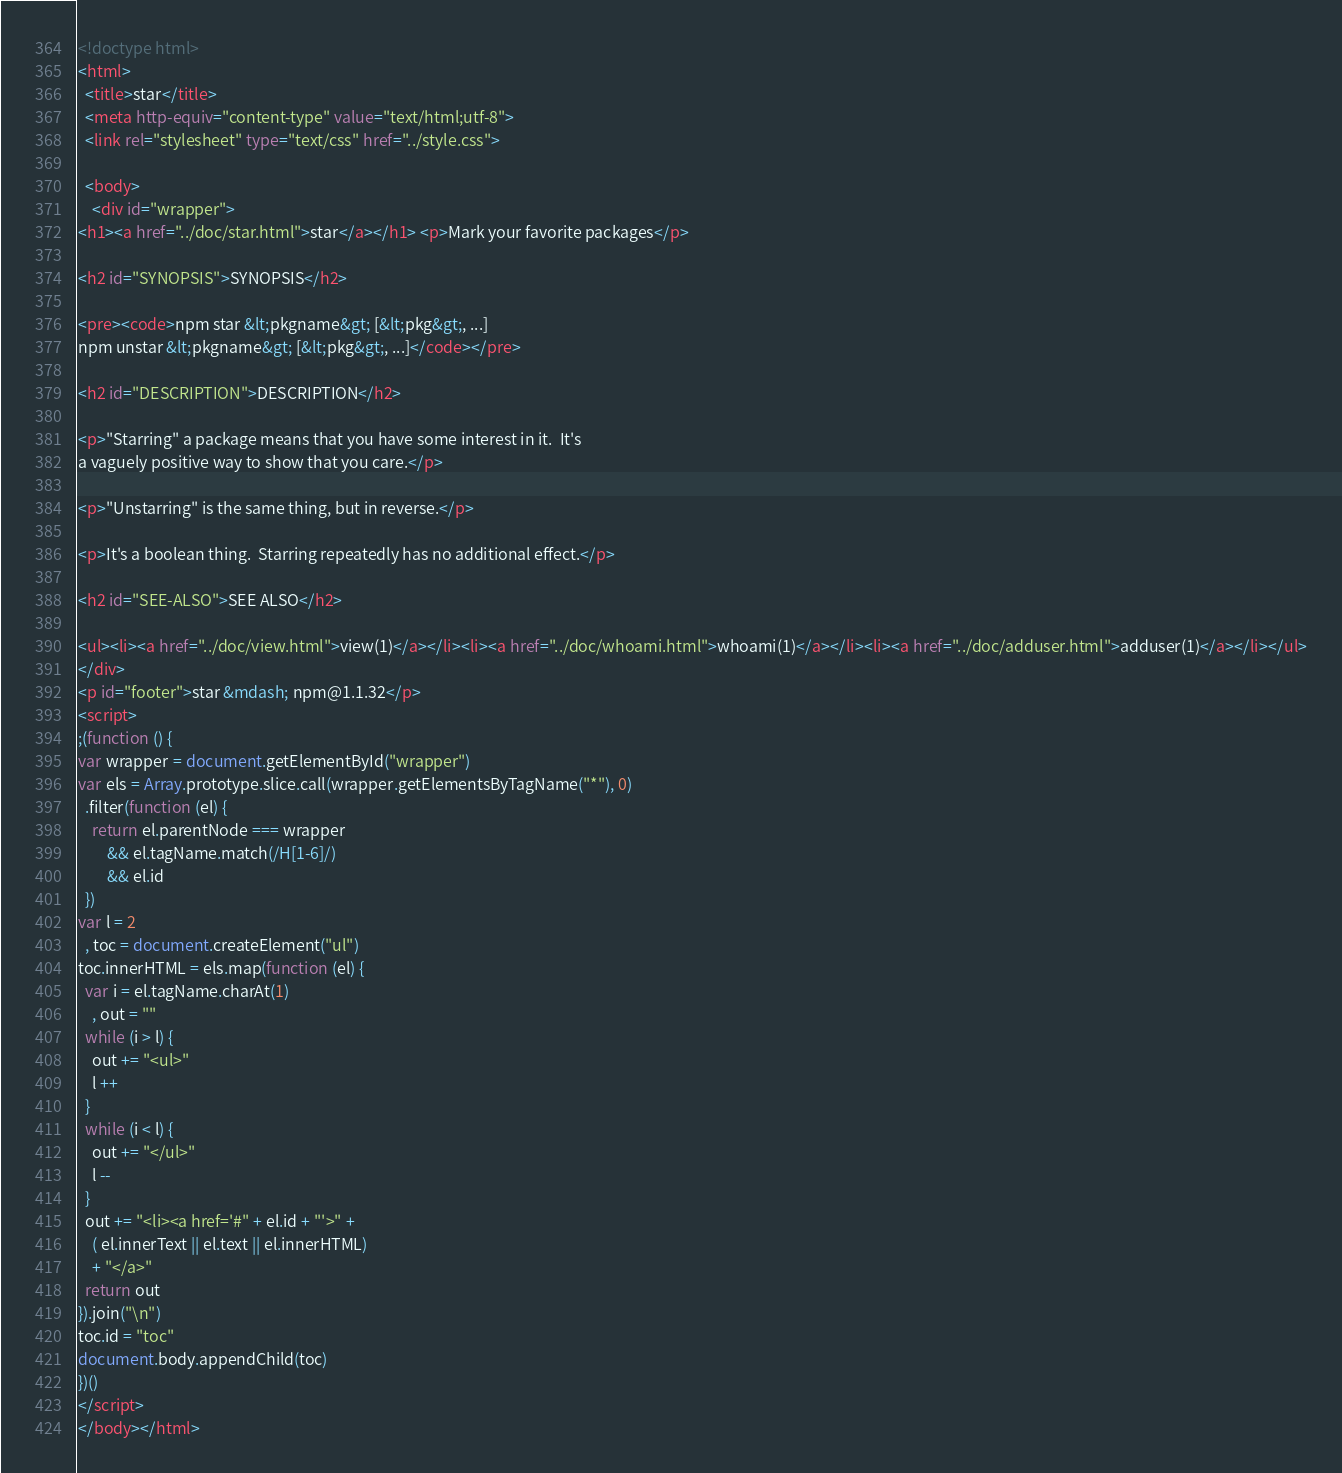Convert code to text. <code><loc_0><loc_0><loc_500><loc_500><_HTML_><!doctype html>
<html>
  <title>star</title>
  <meta http-equiv="content-type" value="text/html;utf-8">
  <link rel="stylesheet" type="text/css" href="../style.css">

  <body>
    <div id="wrapper">
<h1><a href="../doc/star.html">star</a></h1> <p>Mark your favorite packages</p>

<h2 id="SYNOPSIS">SYNOPSIS</h2>

<pre><code>npm star &lt;pkgname&gt; [&lt;pkg&gt;, ...]
npm unstar &lt;pkgname&gt; [&lt;pkg&gt;, ...]</code></pre>

<h2 id="DESCRIPTION">DESCRIPTION</h2>

<p>"Starring" a package means that you have some interest in it.  It's
a vaguely positive way to show that you care.</p>

<p>"Unstarring" is the same thing, but in reverse.</p>

<p>It's a boolean thing.  Starring repeatedly has no additional effect.</p>

<h2 id="SEE-ALSO">SEE ALSO</h2>

<ul><li><a href="../doc/view.html">view(1)</a></li><li><a href="../doc/whoami.html">whoami(1)</a></li><li><a href="../doc/adduser.html">adduser(1)</a></li></ul>
</div>
<p id="footer">star &mdash; npm@1.1.32</p>
<script>
;(function () {
var wrapper = document.getElementById("wrapper")
var els = Array.prototype.slice.call(wrapper.getElementsByTagName("*"), 0)
  .filter(function (el) {
    return el.parentNode === wrapper
        && el.tagName.match(/H[1-6]/)
        && el.id
  })
var l = 2
  , toc = document.createElement("ul")
toc.innerHTML = els.map(function (el) {
  var i = el.tagName.charAt(1)
    , out = ""
  while (i > l) {
    out += "<ul>"
    l ++
  }
  while (i < l) {
    out += "</ul>"
    l --
  }
  out += "<li><a href='#" + el.id + "'>" +
    ( el.innerText || el.text || el.innerHTML)
    + "</a>"
  return out
}).join("\n")
toc.id = "toc"
document.body.appendChild(toc)
})()
</script>
</body></html>
</code> 